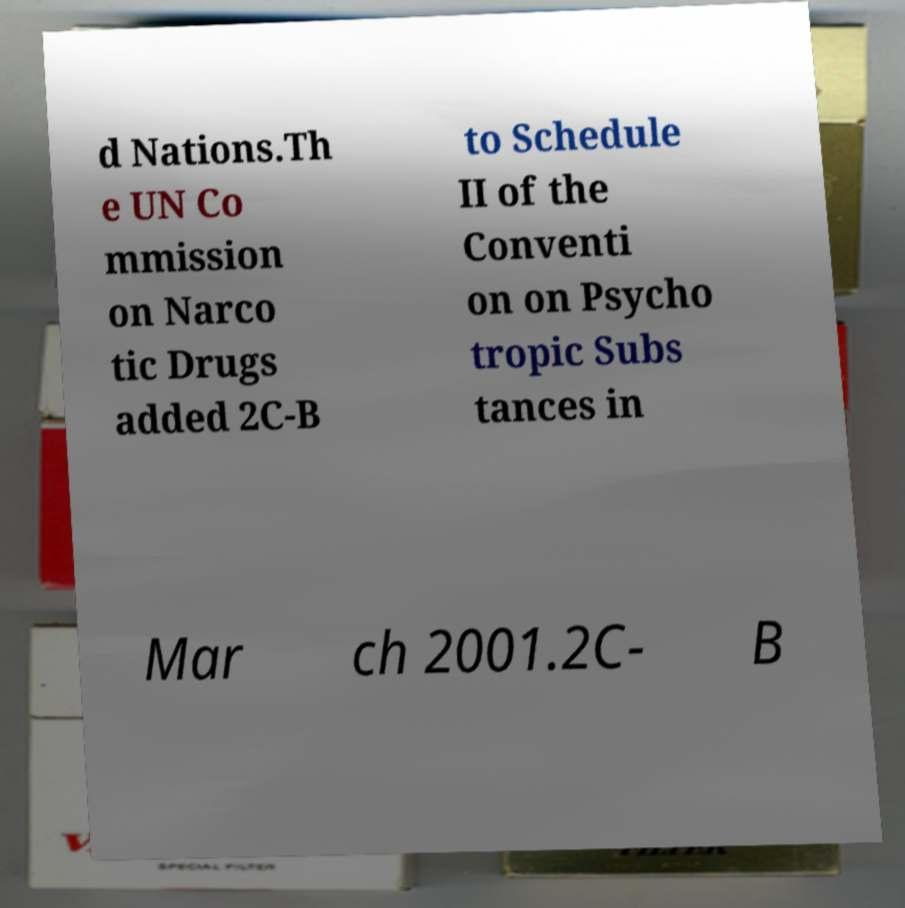Can you read and provide the text displayed in the image?This photo seems to have some interesting text. Can you extract and type it out for me? d Nations.Th e UN Co mmission on Narco tic Drugs added 2C-B to Schedule II of the Conventi on on Psycho tropic Subs tances in Mar ch 2001.2C- B 